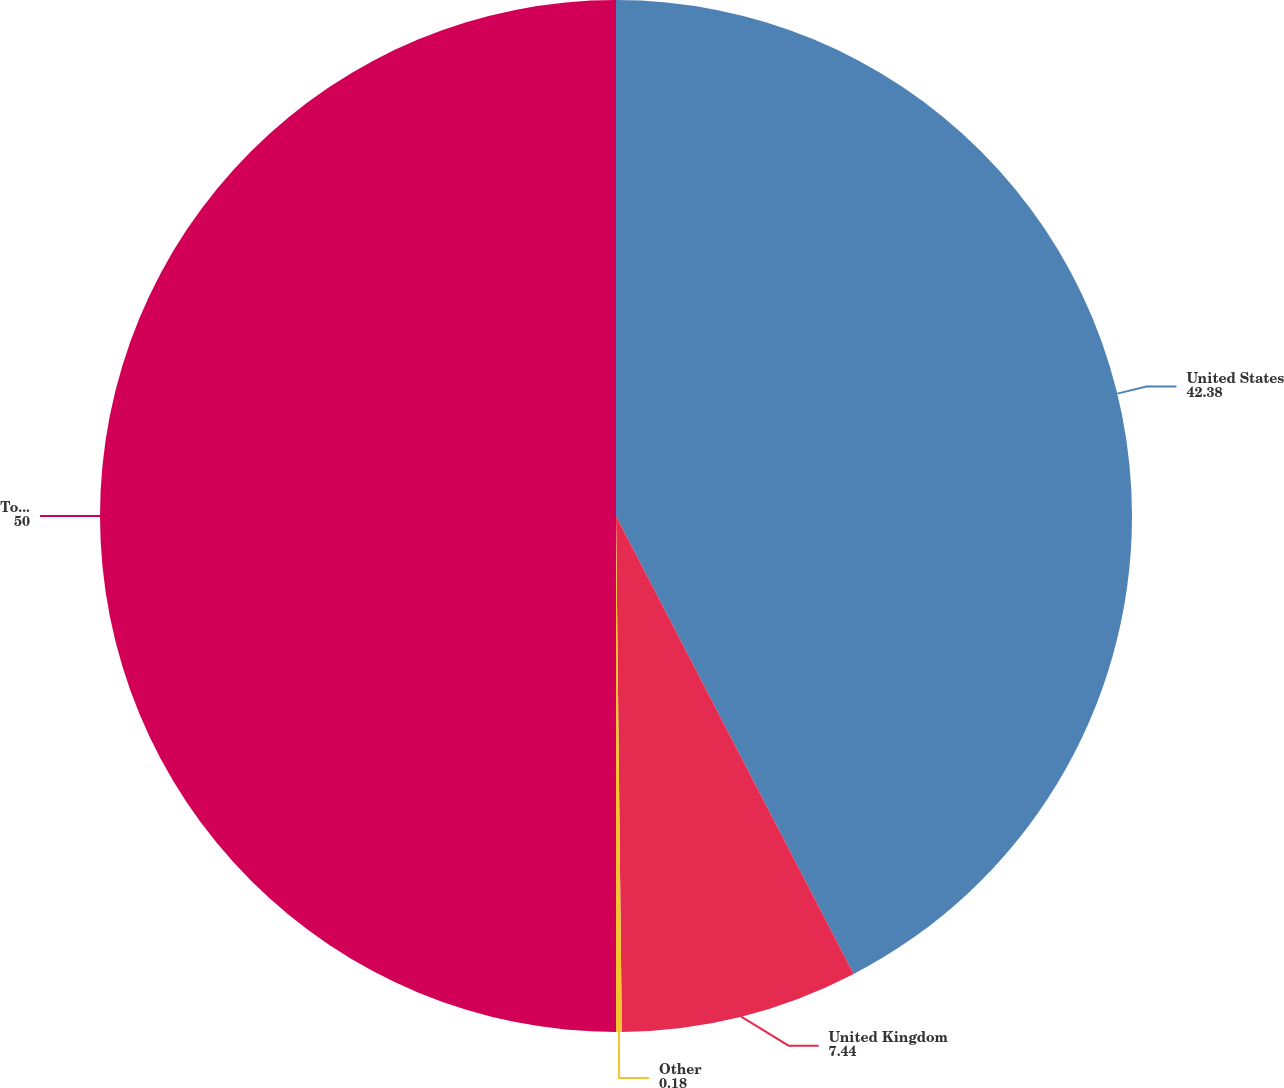Convert chart to OTSL. <chart><loc_0><loc_0><loc_500><loc_500><pie_chart><fcel>United States<fcel>United Kingdom<fcel>Other<fcel>Total<nl><fcel>42.38%<fcel>7.44%<fcel>0.18%<fcel>50.0%<nl></chart> 